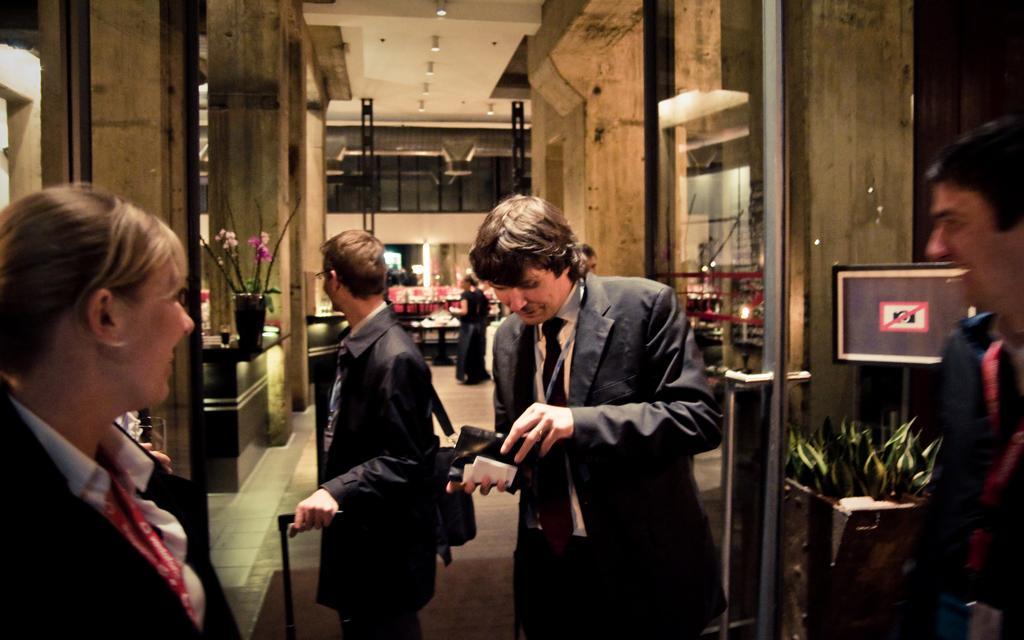Can you describe this image briefly? In this image we can see a group of people standing on the floor. In that a person is holding a walking stick and the other is holding a book. We can also see some plants and a board. On the left side we can see the hand of a person holding a glass. On the backside we can see a flower pot and a glass which are placed on the table, some pillars, windows and a roof with some ceiling lights. 